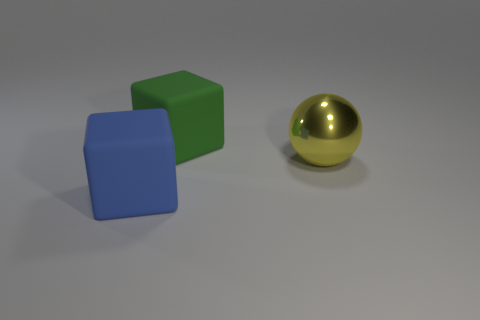There is a rubber object to the left of the big block that is on the right side of the big blue matte block; what color is it?
Make the answer very short. Blue. The big sphere behind the matte thing that is on the left side of the large matte object behind the blue rubber object is made of what material?
Give a very brief answer. Metal. How many green blocks have the same size as the ball?
Provide a succinct answer. 1. There is a thing that is both in front of the large green block and behind the big blue rubber block; what material is it?
Provide a short and direct response. Metal. There is a yellow metal sphere; how many large cubes are right of it?
Ensure brevity in your answer.  0. There is a blue object; does it have the same shape as the large rubber object right of the blue cube?
Your answer should be very brief. Yes. Is there a big blue rubber thing of the same shape as the green thing?
Give a very brief answer. Yes. What shape is the large thing right of the thing behind the large yellow metallic object?
Your answer should be very brief. Sphere. The large matte thing behind the large yellow metallic object has what shape?
Make the answer very short. Cube. Do the matte thing in front of the metallic sphere and the rubber object that is behind the blue object have the same color?
Ensure brevity in your answer.  No. 